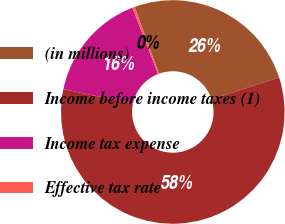Convert chart. <chart><loc_0><loc_0><loc_500><loc_500><pie_chart><fcel>(in millions)<fcel>Income before income taxes (1)<fcel>Income tax expense<fcel>Effective tax rate<nl><fcel>25.55%<fcel>58.26%<fcel>15.85%<fcel>0.34%<nl></chart> 